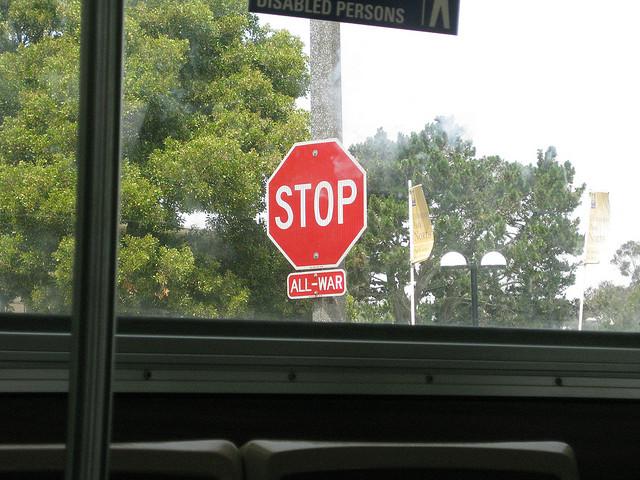What color is the stop sign?
Be succinct. Red. What does the sign say?
Write a very short answer. Stop. Is this outside?
Write a very short answer. Yes. 